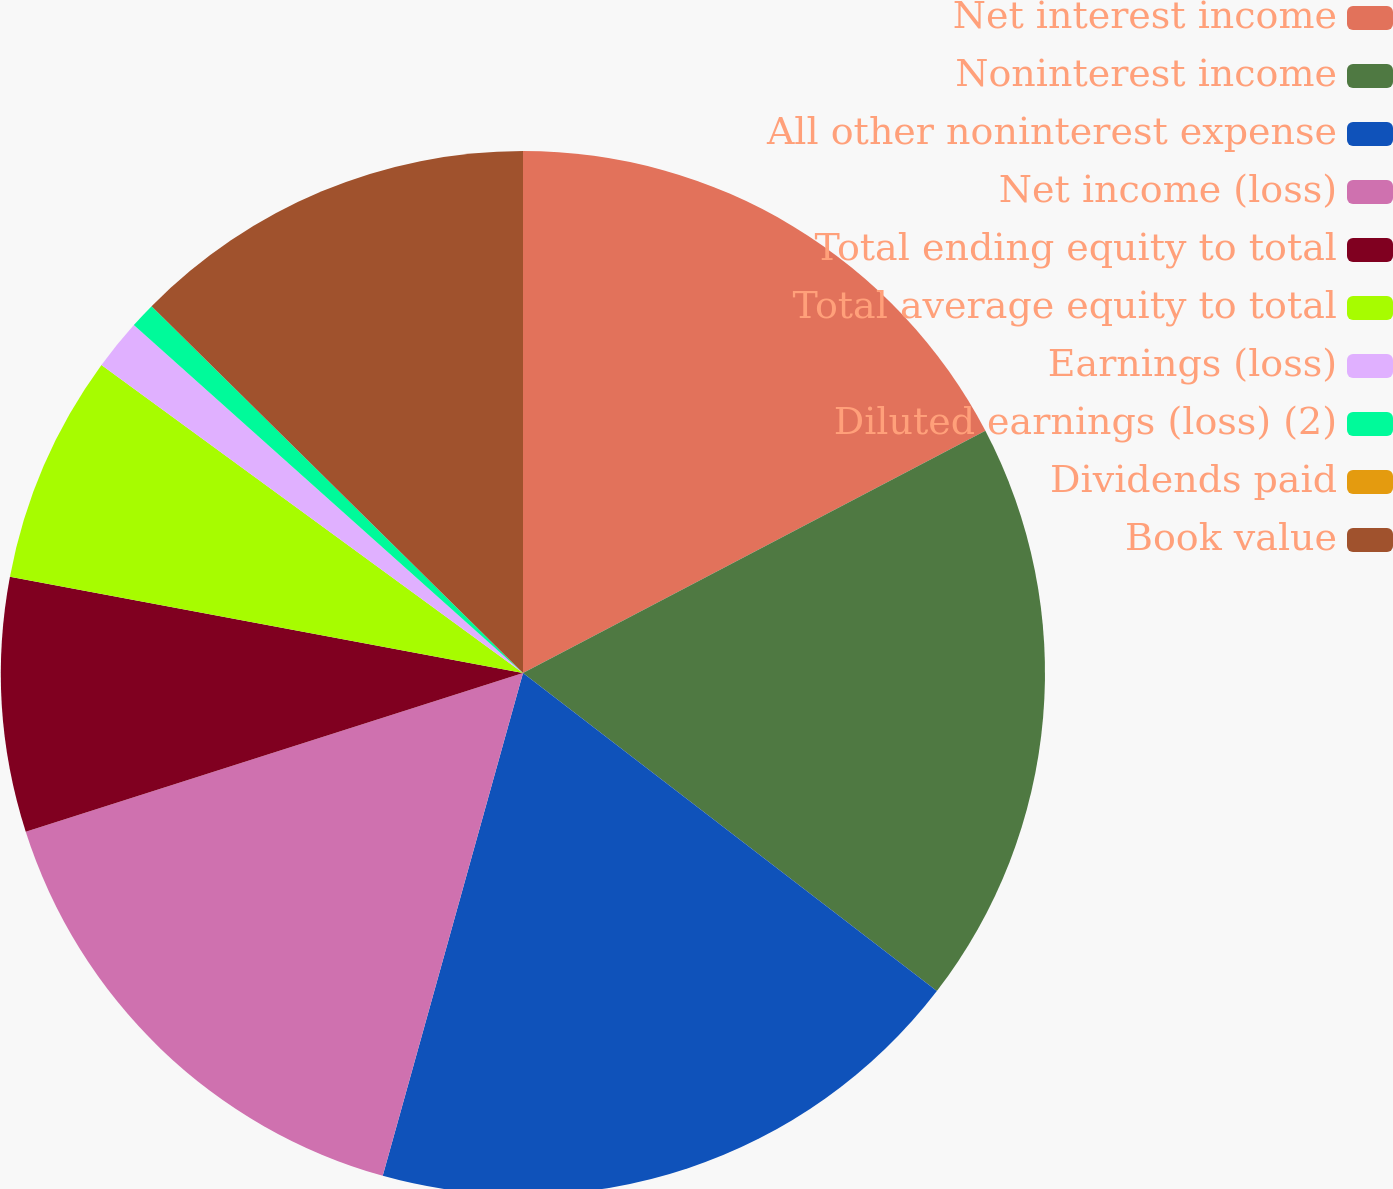Convert chart to OTSL. <chart><loc_0><loc_0><loc_500><loc_500><pie_chart><fcel>Net interest income<fcel>Noninterest income<fcel>All other noninterest expense<fcel>Net income (loss)<fcel>Total ending equity to total<fcel>Total average equity to total<fcel>Earnings (loss)<fcel>Diluted earnings (loss) (2)<fcel>Dividends paid<fcel>Book value<nl><fcel>17.32%<fcel>18.11%<fcel>18.9%<fcel>15.75%<fcel>7.87%<fcel>7.09%<fcel>1.57%<fcel>0.79%<fcel>0.0%<fcel>12.6%<nl></chart> 